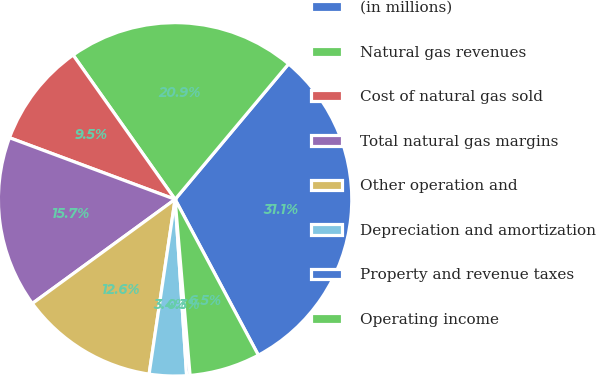Convert chart to OTSL. <chart><loc_0><loc_0><loc_500><loc_500><pie_chart><fcel>(in millions)<fcel>Natural gas revenues<fcel>Cost of natural gas sold<fcel>Total natural gas margins<fcel>Other operation and<fcel>Depreciation and amortization<fcel>Property and revenue taxes<fcel>Operating income<nl><fcel>31.09%<fcel>20.89%<fcel>9.54%<fcel>15.7%<fcel>12.62%<fcel>3.39%<fcel>0.31%<fcel>6.46%<nl></chart> 